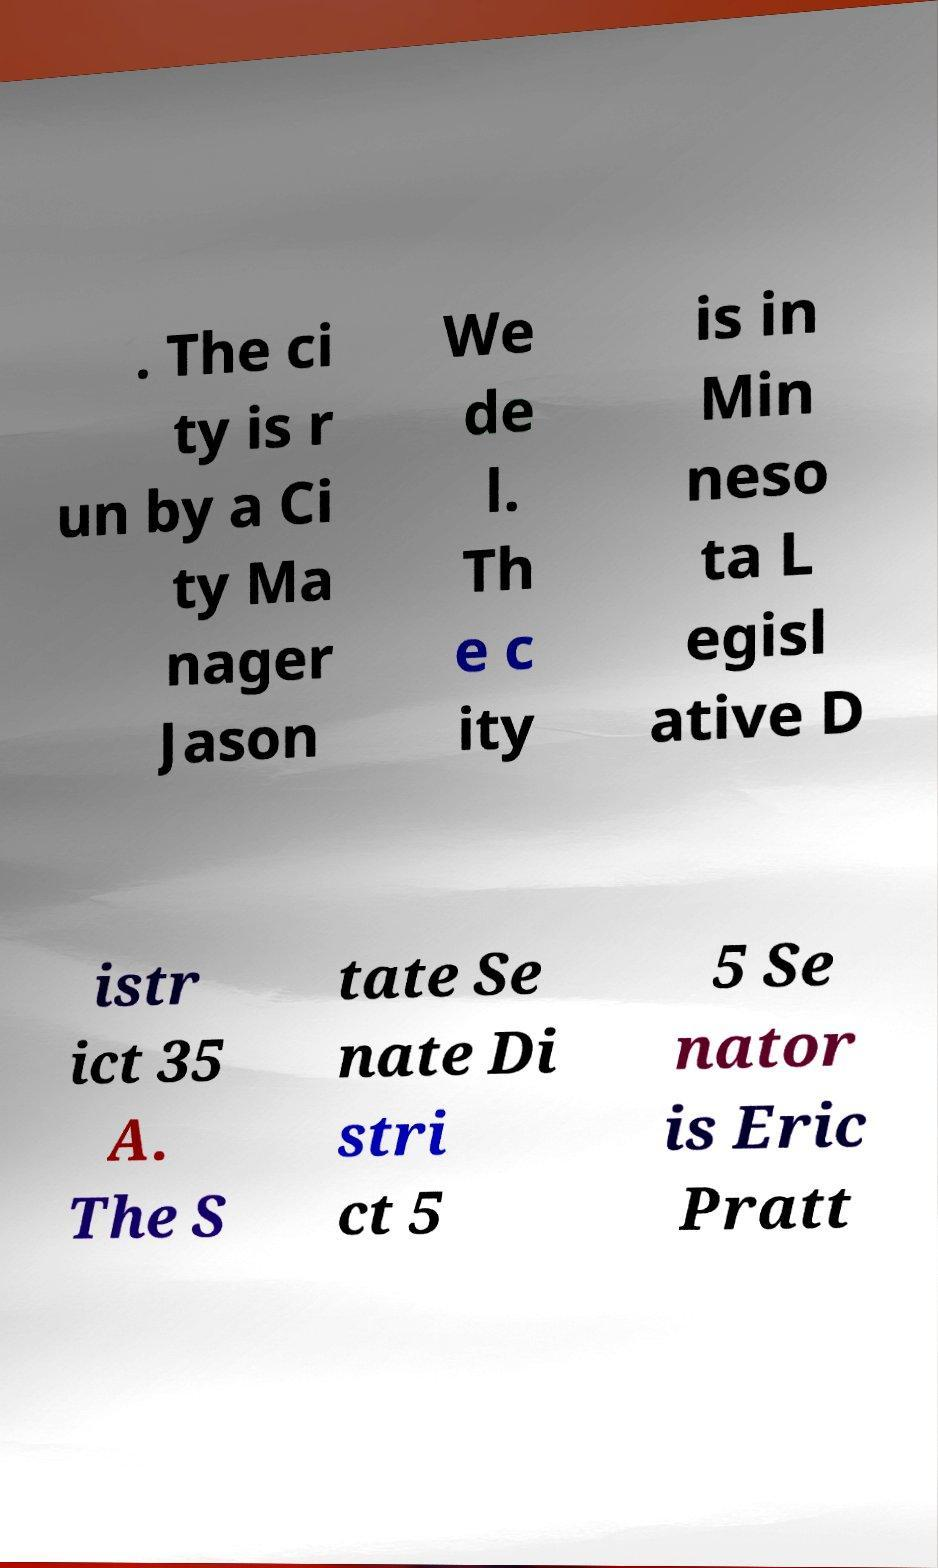Could you extract and type out the text from this image? . The ci ty is r un by a Ci ty Ma nager Jason We de l. Th e c ity is in Min neso ta L egisl ative D istr ict 35 A. The S tate Se nate Di stri ct 5 5 Se nator is Eric Pratt 